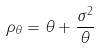Convert formula to latex. <formula><loc_0><loc_0><loc_500><loc_500>\rho _ { \theta } = \theta + \frac { \sigma ^ { 2 } } { \theta }</formula> 